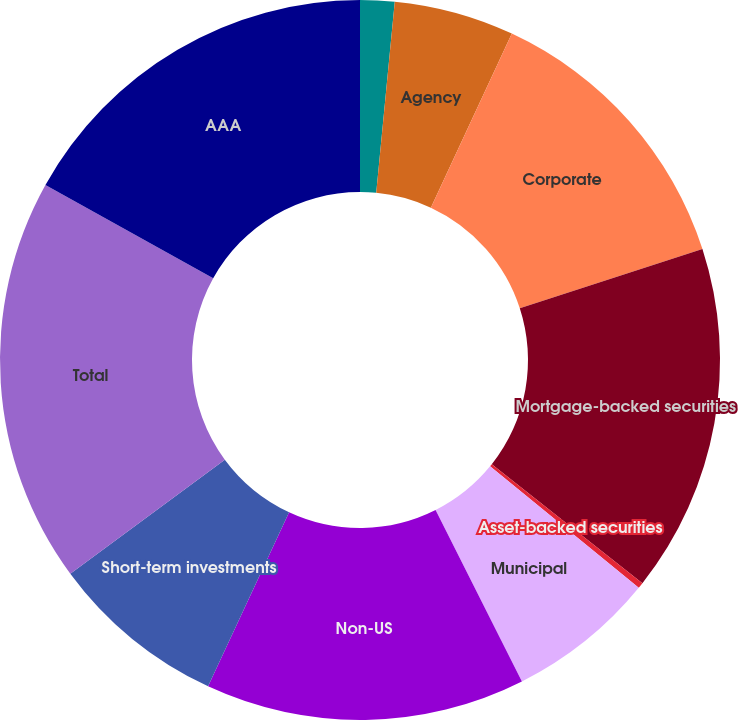Convert chart. <chart><loc_0><loc_0><loc_500><loc_500><pie_chart><fcel>Treasury<fcel>Agency<fcel>Corporate<fcel>Mortgage-backed securities<fcel>Asset-backed securities<fcel>Municipal<fcel>Non-US<fcel>Short-term investments<fcel>Total<fcel>AAA<nl><fcel>1.54%<fcel>5.39%<fcel>13.08%<fcel>15.64%<fcel>0.26%<fcel>6.67%<fcel>14.36%<fcel>7.95%<fcel>18.2%<fcel>16.92%<nl></chart> 